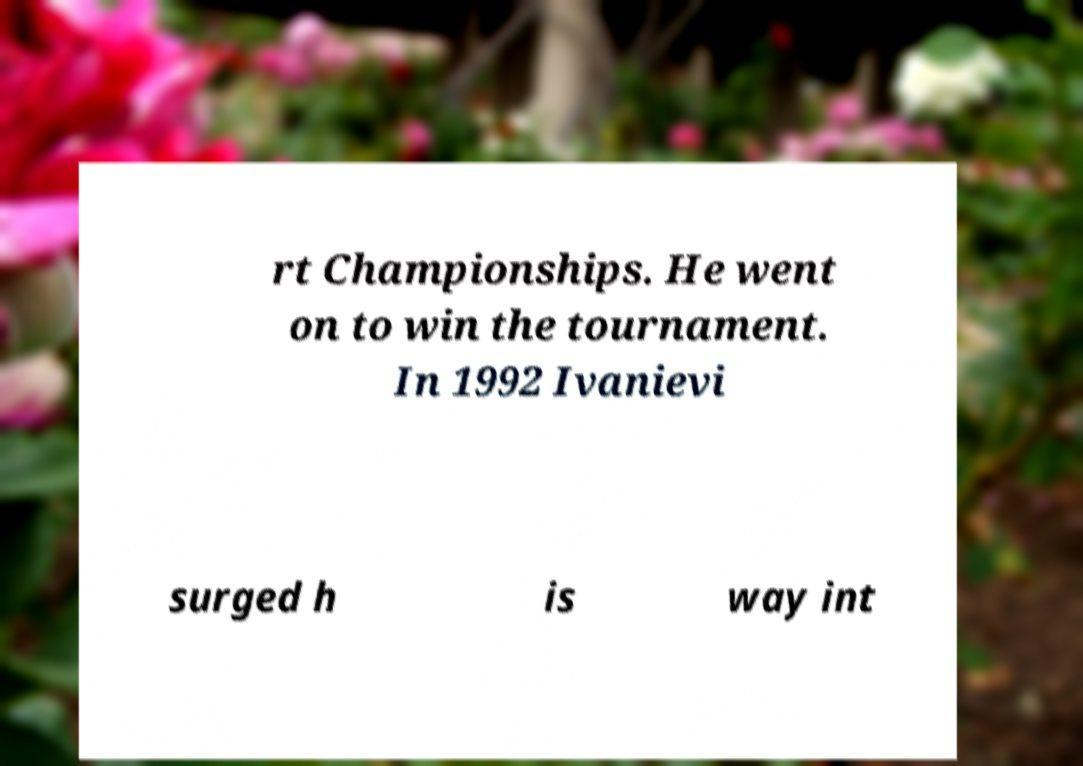I need the written content from this picture converted into text. Can you do that? rt Championships. He went on to win the tournament. In 1992 Ivanievi surged h is way int 